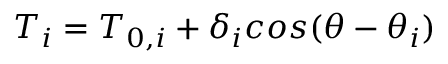Convert formula to latex. <formula><loc_0><loc_0><loc_500><loc_500>T _ { i } = T _ { 0 , i } + \delta _ { i } \cos ( \theta - \theta _ { i } )</formula> 